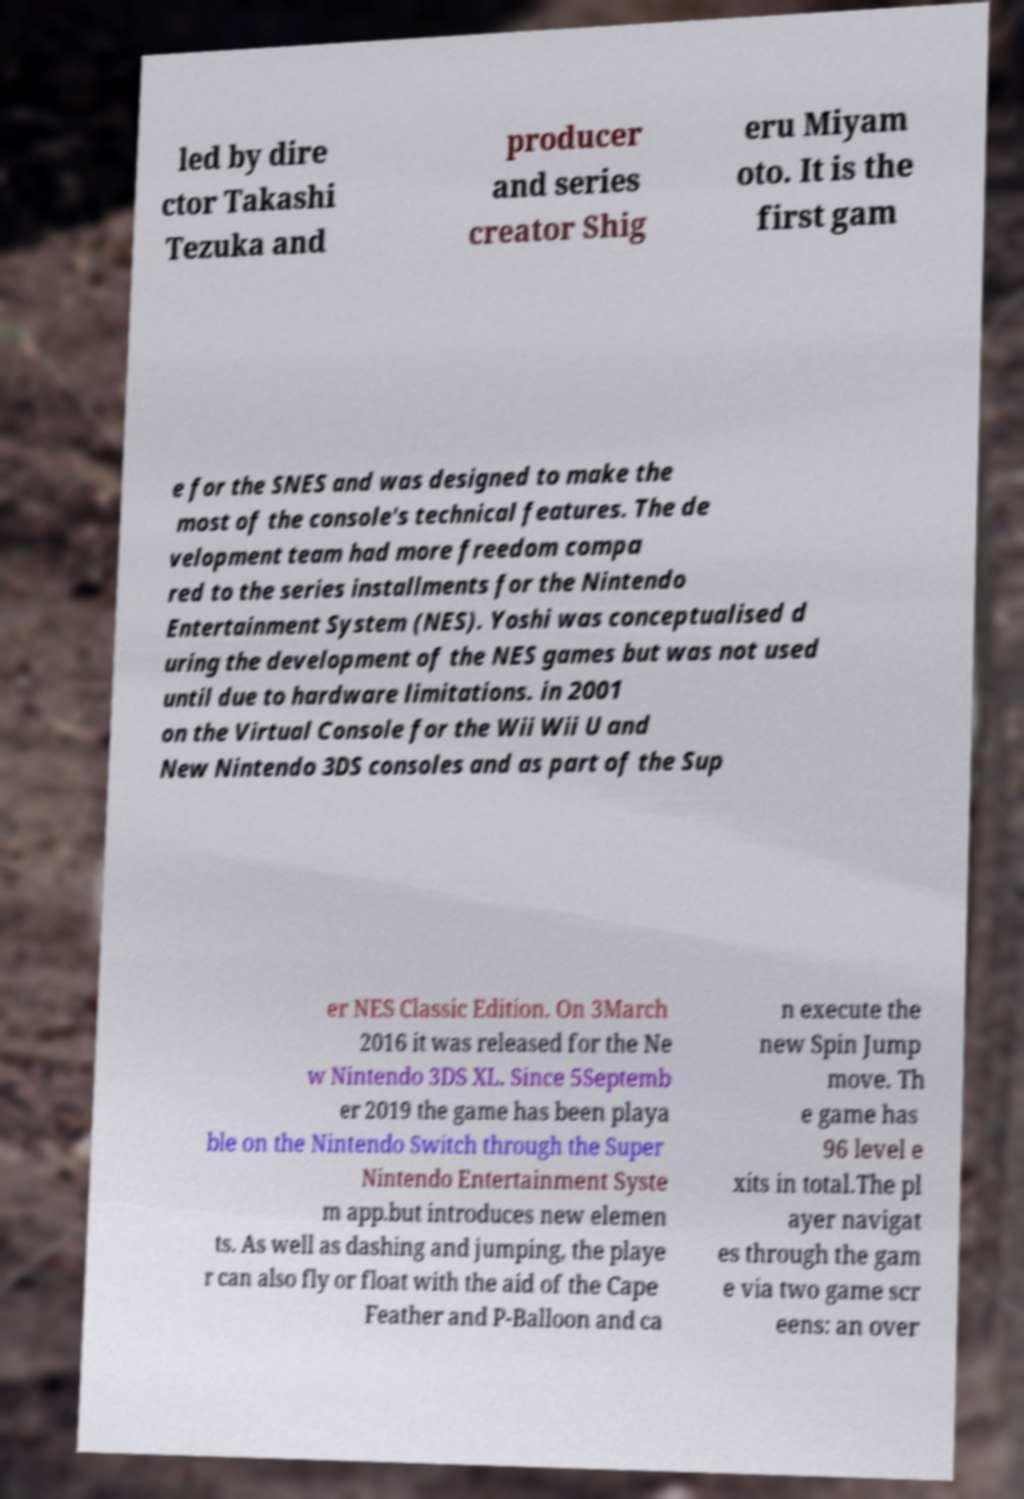What messages or text are displayed in this image? I need them in a readable, typed format. led by dire ctor Takashi Tezuka and producer and series creator Shig eru Miyam oto. It is the first gam e for the SNES and was designed to make the most of the console's technical features. The de velopment team had more freedom compa red to the series installments for the Nintendo Entertainment System (NES). Yoshi was conceptualised d uring the development of the NES games but was not used until due to hardware limitations. in 2001 on the Virtual Console for the Wii Wii U and New Nintendo 3DS consoles and as part of the Sup er NES Classic Edition. On 3March 2016 it was released for the Ne w Nintendo 3DS XL. Since 5Septemb er 2019 the game has been playa ble on the Nintendo Switch through the Super Nintendo Entertainment Syste m app.but introduces new elemen ts. As well as dashing and jumping, the playe r can also fly or float with the aid of the Cape Feather and P-Balloon and ca n execute the new Spin Jump move. Th e game has 96 level e xits in total.The pl ayer navigat es through the gam e via two game scr eens: an over 